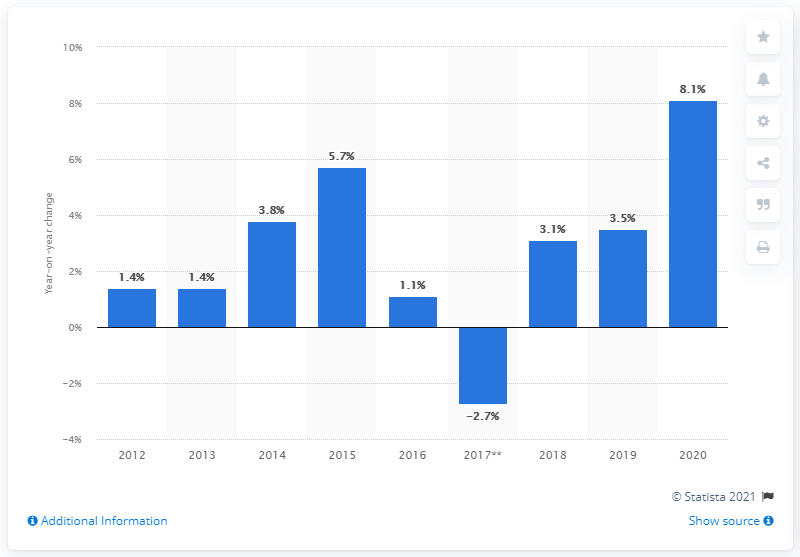Highlight a few significant elements in this photo. In December 2020, the retail sales of furniture and home furnishings stores in Canada increased by 8.1% compared to December 2019. 